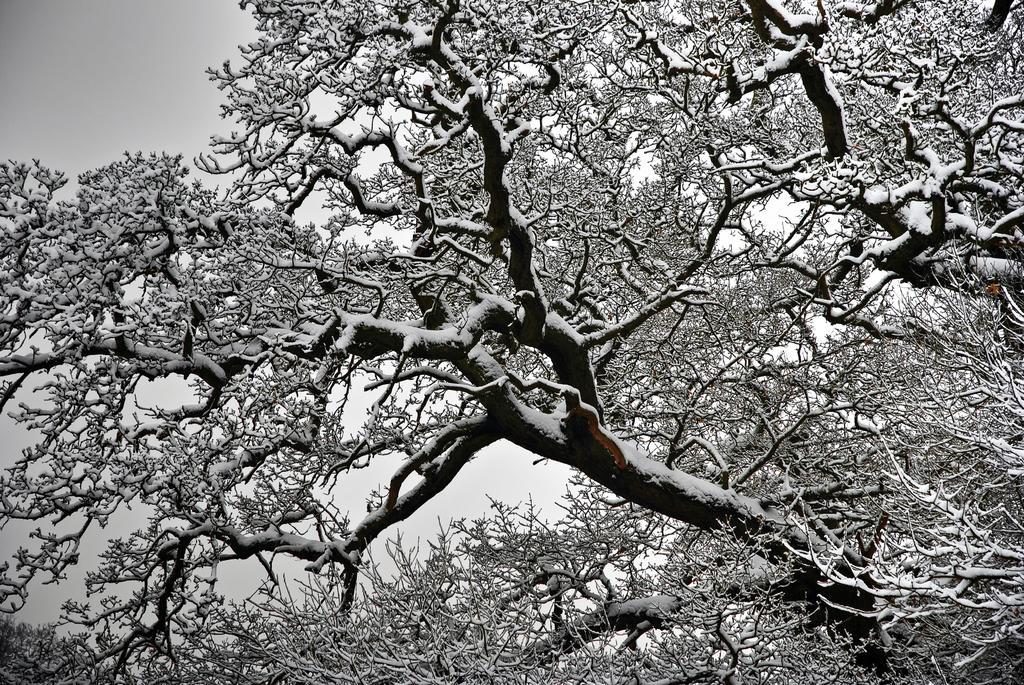How would you summarize this image in a sentence or two? In this image we can see the black and white picture and there are trees and the sky. 